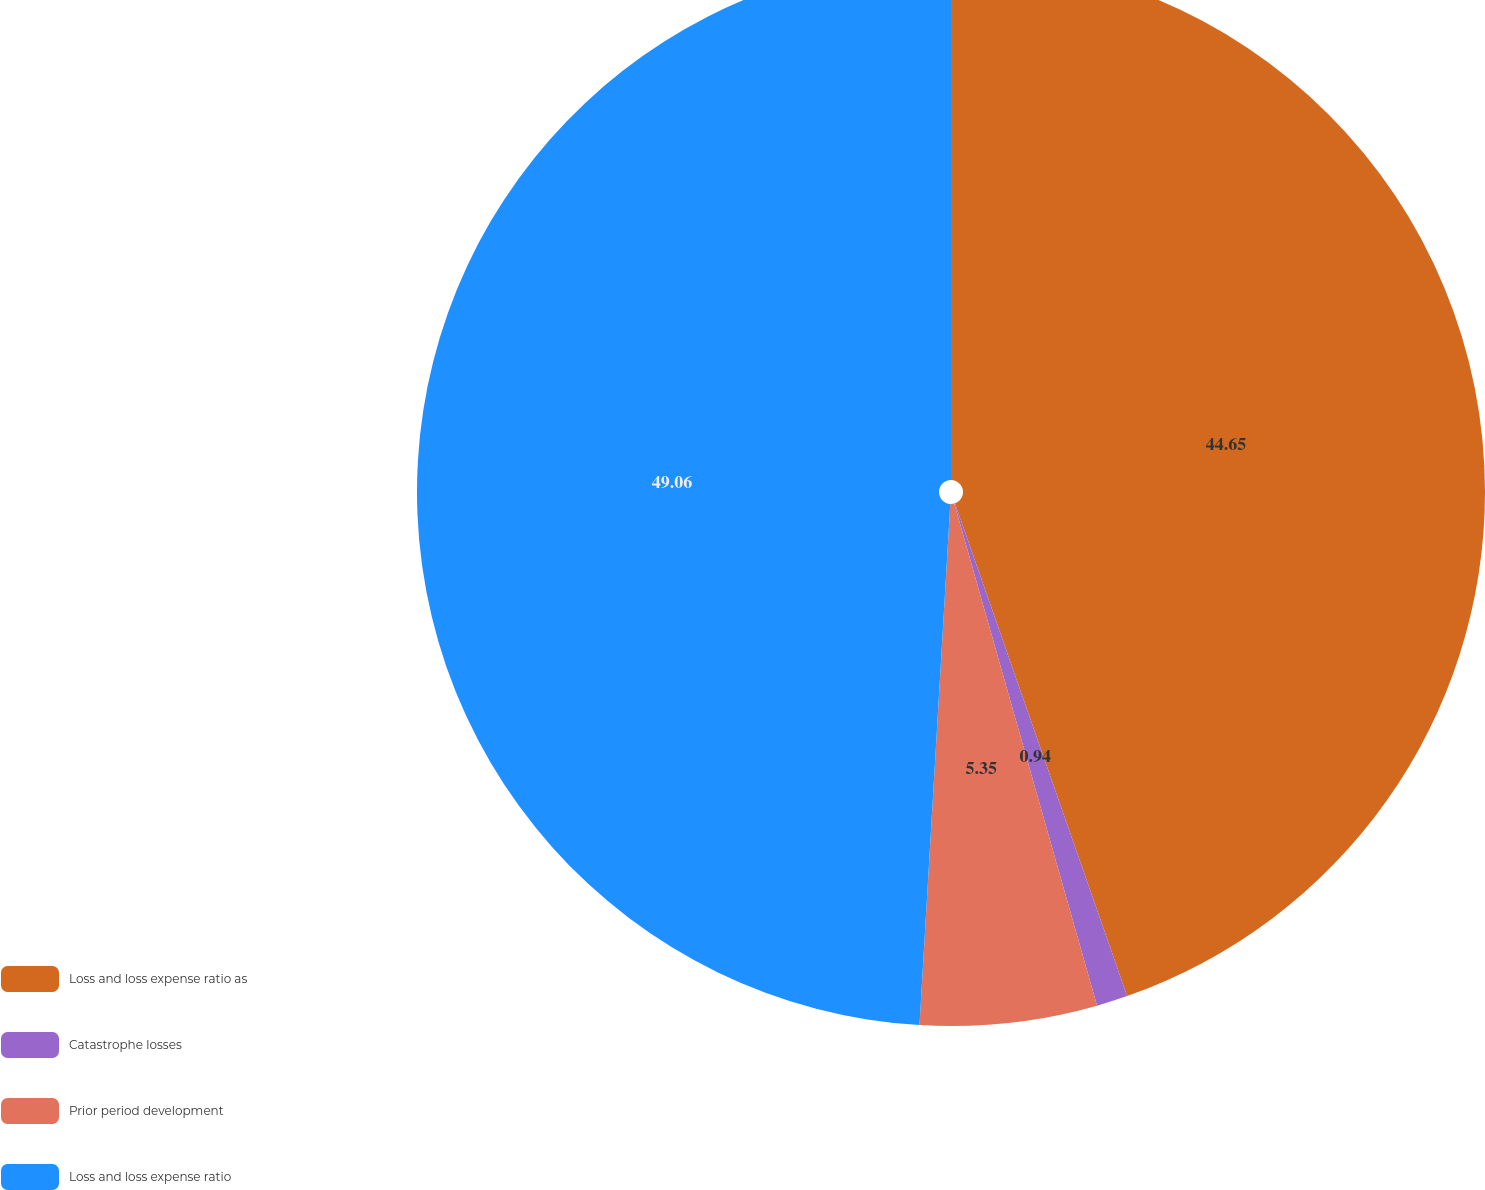<chart> <loc_0><loc_0><loc_500><loc_500><pie_chart><fcel>Loss and loss expense ratio as<fcel>Catastrophe losses<fcel>Prior period development<fcel>Loss and loss expense ratio<nl><fcel>44.65%<fcel>0.94%<fcel>5.35%<fcel>49.06%<nl></chart> 